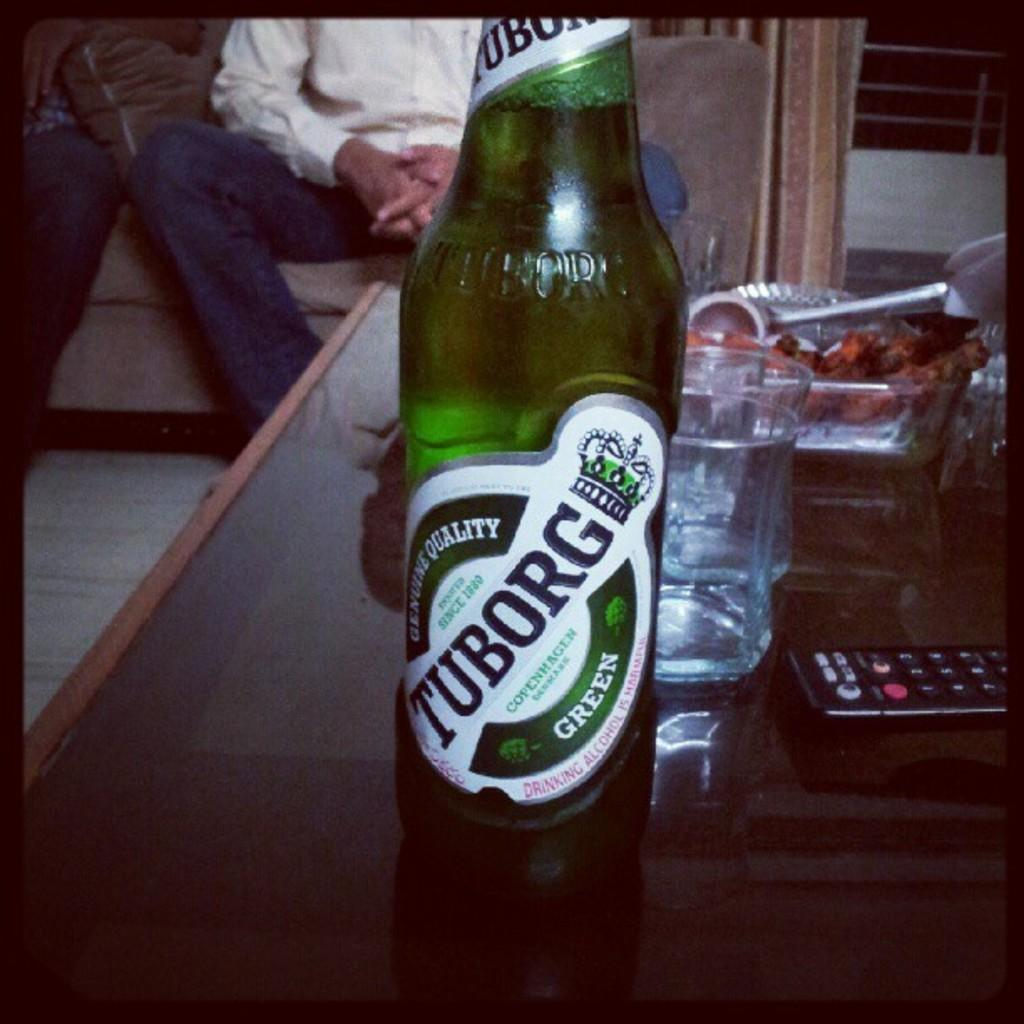<image>
Give a short and clear explanation of the subsequent image. A bottle of Tuborg Green alcohol sits on a coffee table. 